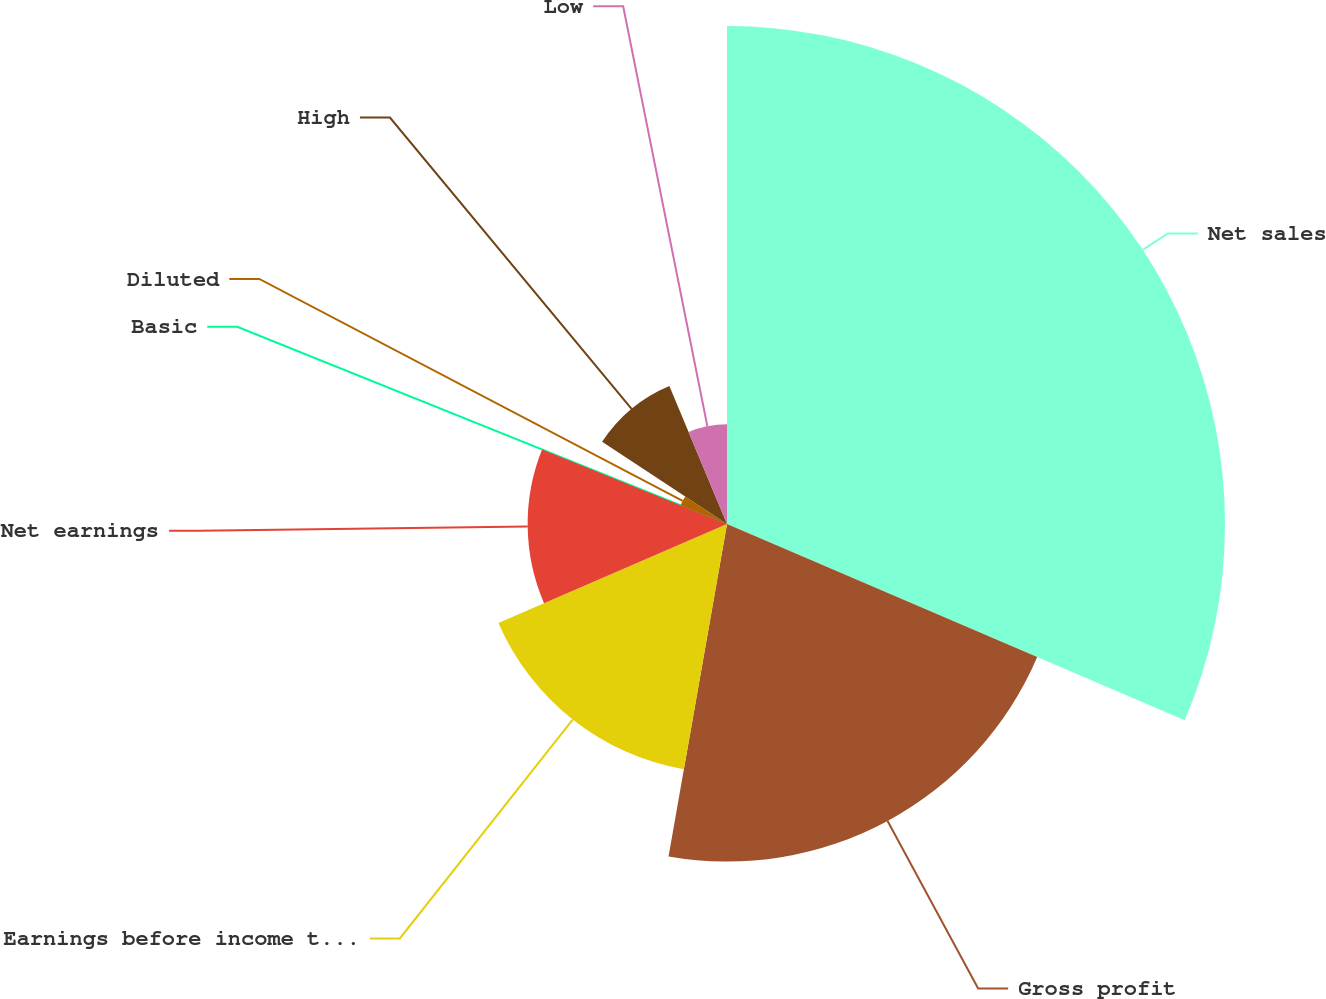Convert chart. <chart><loc_0><loc_0><loc_500><loc_500><pie_chart><fcel>Net sales<fcel>Gross profit<fcel>Earnings before income taxes<fcel>Net earnings<fcel>Basic<fcel>Diluted<fcel>High<fcel>Low<nl><fcel>31.45%<fcel>21.32%<fcel>15.73%<fcel>12.59%<fcel>0.01%<fcel>3.16%<fcel>9.44%<fcel>6.3%<nl></chart> 